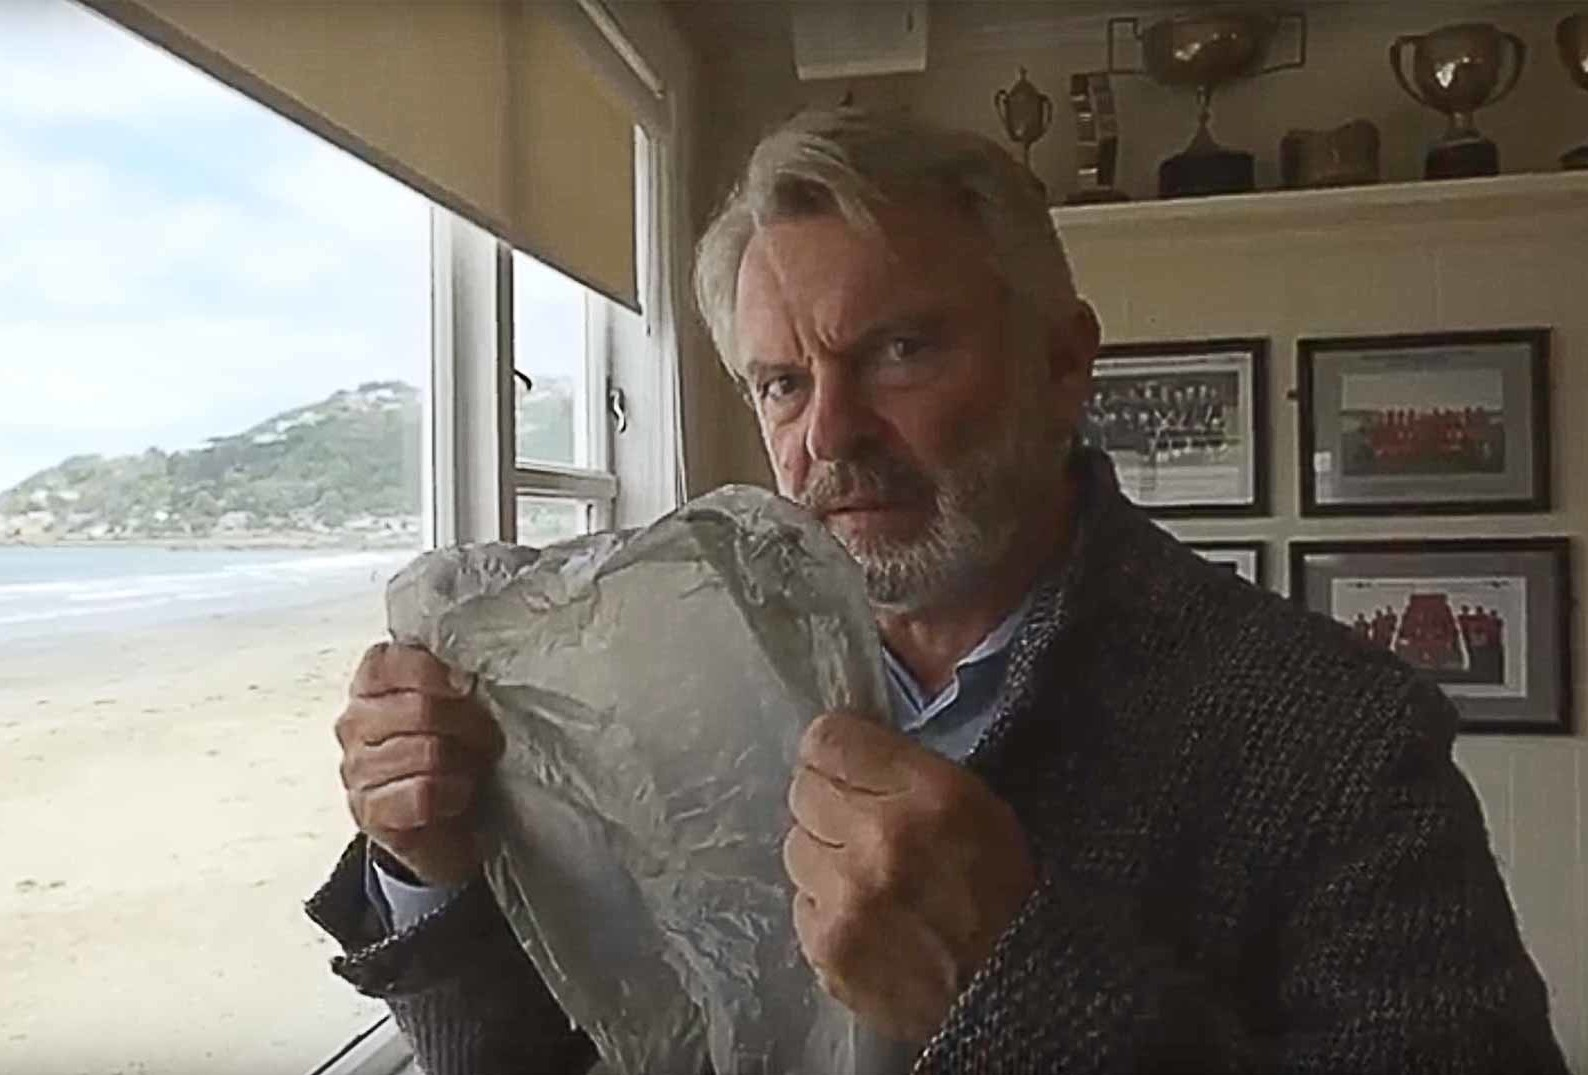Can you tell what the trophies in the background might indicate about the person? The trophies in the background seem to indicate a history of achievements, likely in a professional or personal capacity. Given their prominent display in a personal space, they might relate to significant accomplishments in his career or possibly personal hobbies where he has excelled. Such a setting suggests pride in these achievements and a strong personal connection to them. 